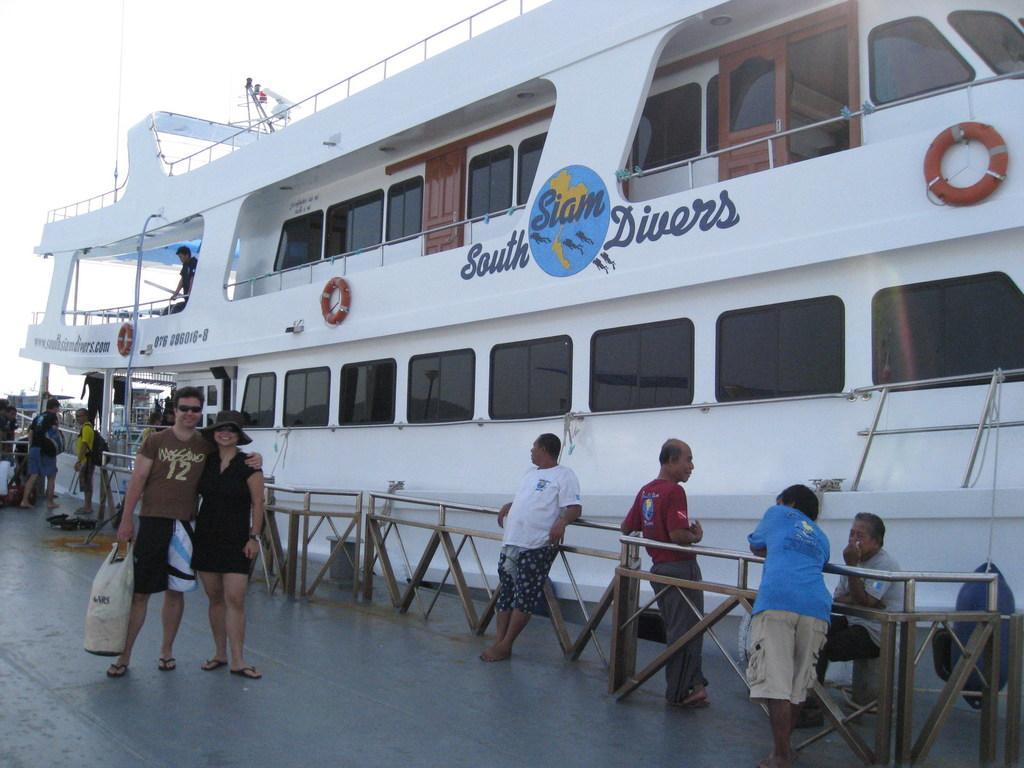How would you summarize this image in a sentence or two? In this picture we can see the white cruise is parked in the front. on which south drive is written. In the front we can see the couple taking photograph. On the right side we can see some people standing near the wooden railing. 